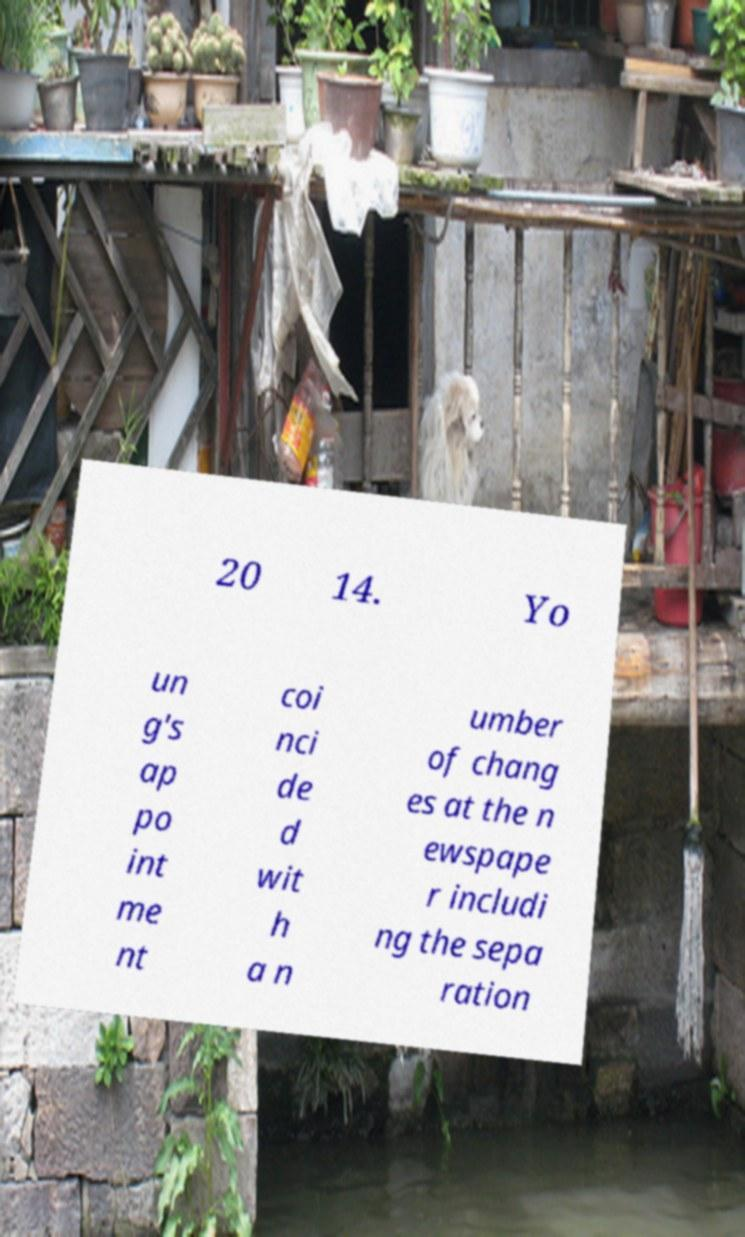Could you assist in decoding the text presented in this image and type it out clearly? 20 14. Yo un g's ap po int me nt coi nci de d wit h a n umber of chang es at the n ewspape r includi ng the sepa ration 